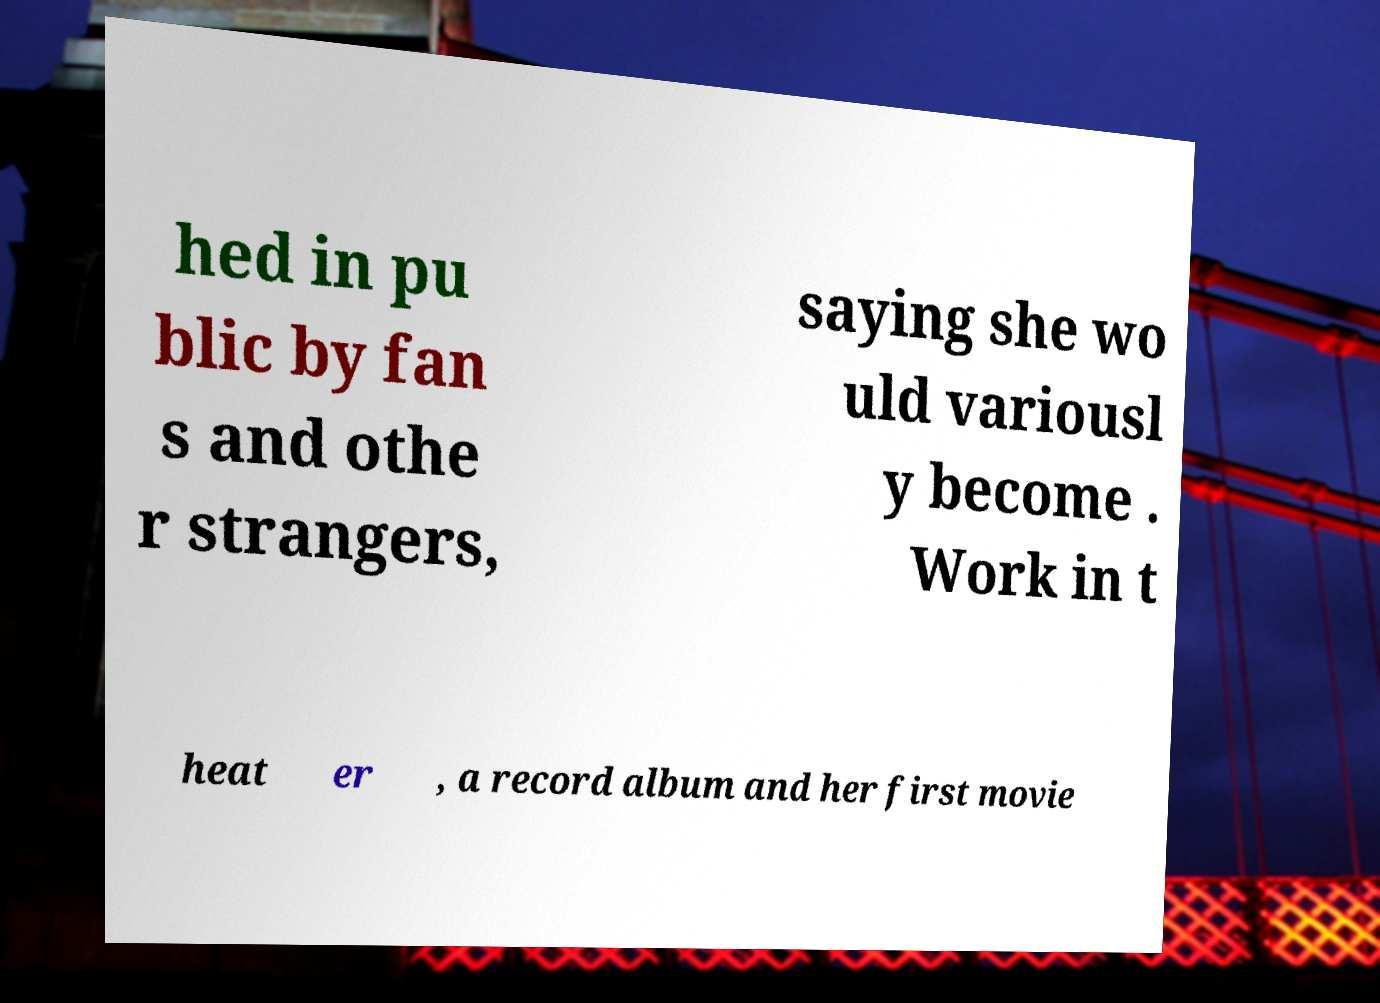Can you read and provide the text displayed in the image?This photo seems to have some interesting text. Can you extract and type it out for me? hed in pu blic by fan s and othe r strangers, saying she wo uld variousl y become . Work in t heat er , a record album and her first movie 